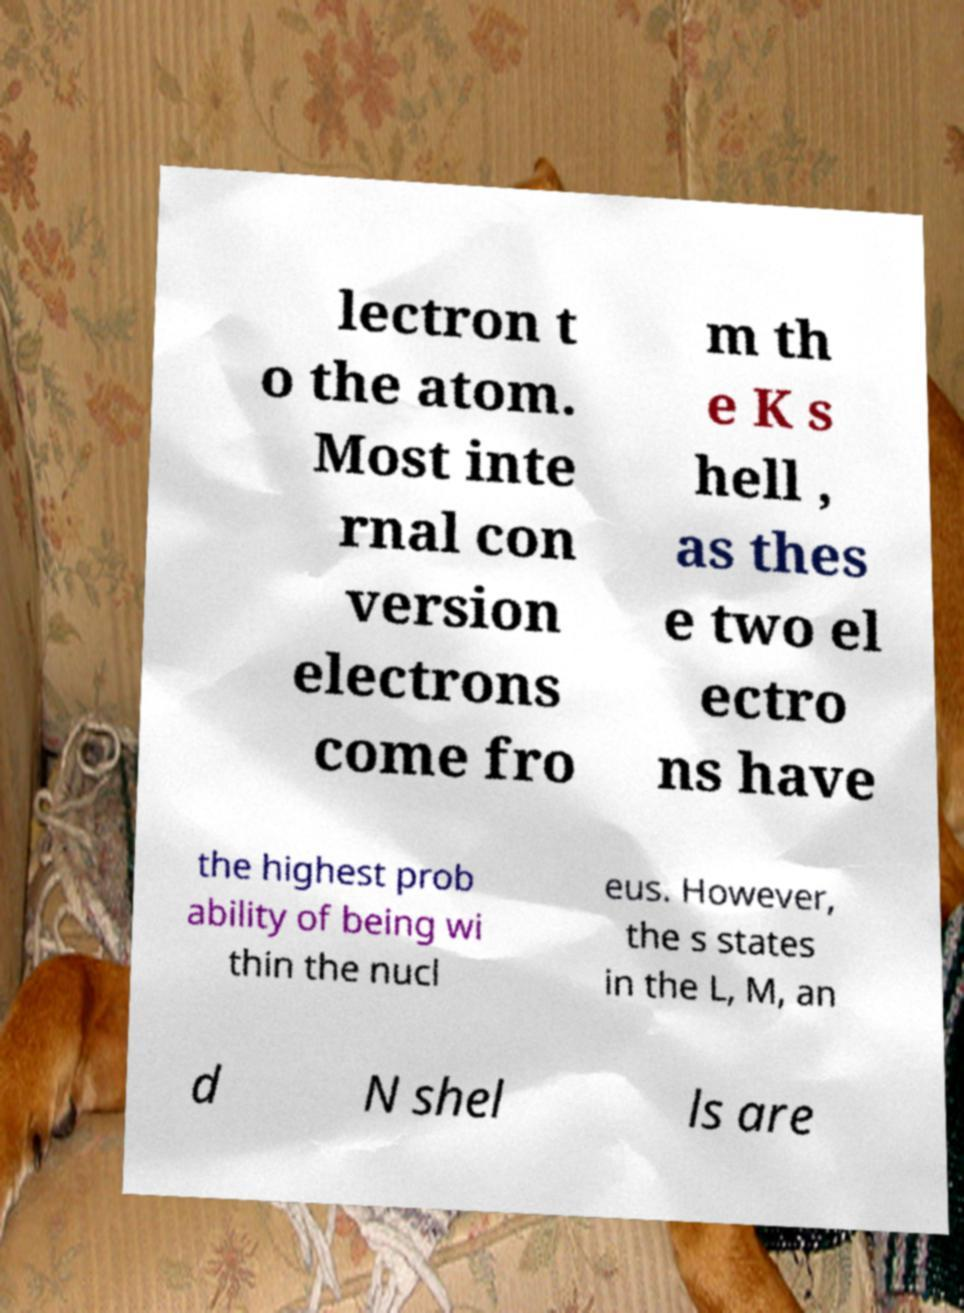What messages or text are displayed in this image? I need them in a readable, typed format. lectron t o the atom. Most inte rnal con version electrons come fro m th e K s hell , as thes e two el ectro ns have the highest prob ability of being wi thin the nucl eus. However, the s states in the L, M, an d N shel ls are 